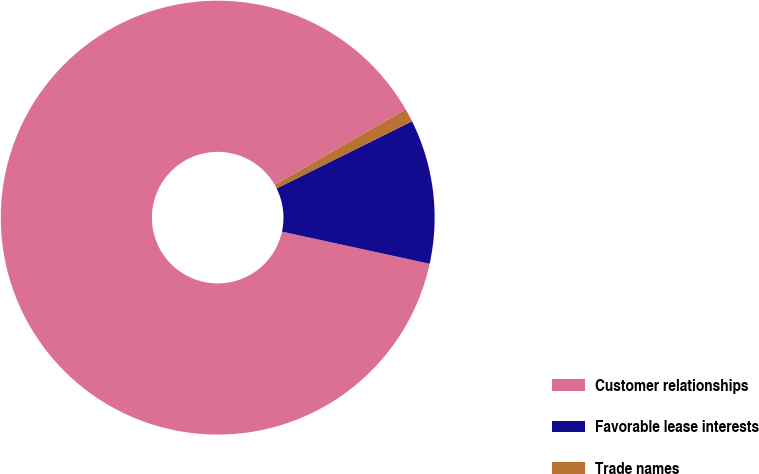<chart> <loc_0><loc_0><loc_500><loc_500><pie_chart><fcel>Customer relationships<fcel>Favorable lease interests<fcel>Trade names<nl><fcel>88.28%<fcel>10.74%<fcel>0.98%<nl></chart> 